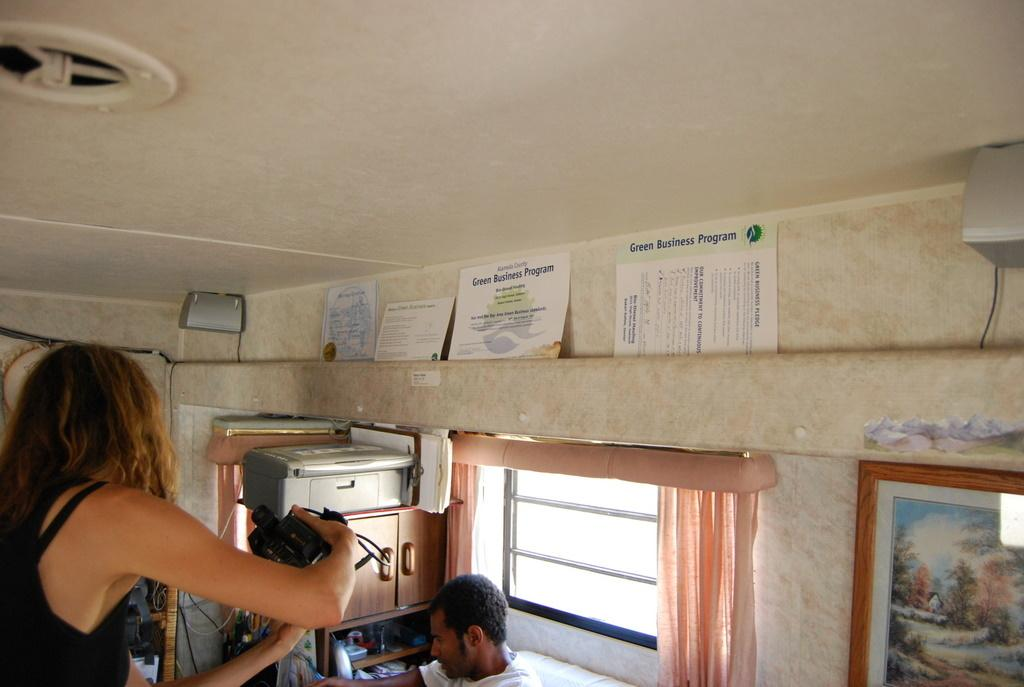<image>
Give a short and clear explanation of the subsequent image. People inside an RV with a piece of paper on the wall that says Green Business Program. 